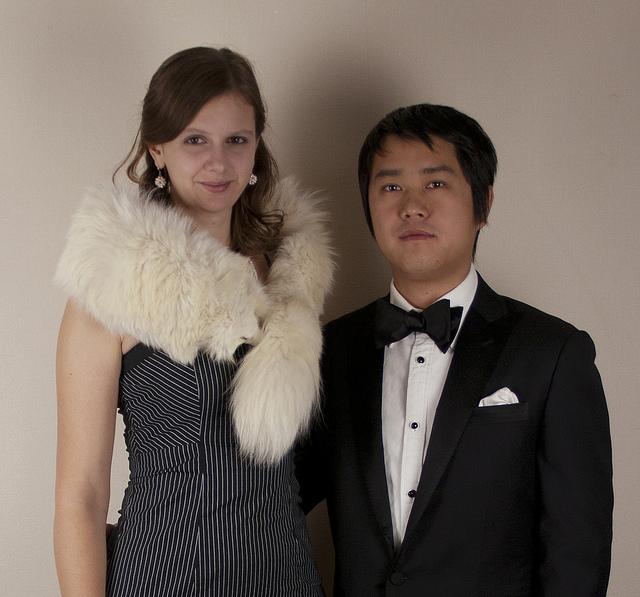What is the woman wearing around her shoulders?
Be succinct. Fur. What color is the man's bow tie?
Quick response, please. Black. Would you wear this to a formal occasion?
Quick response, please. Yes. Does this couple really look happy?
Give a very brief answer. No. 